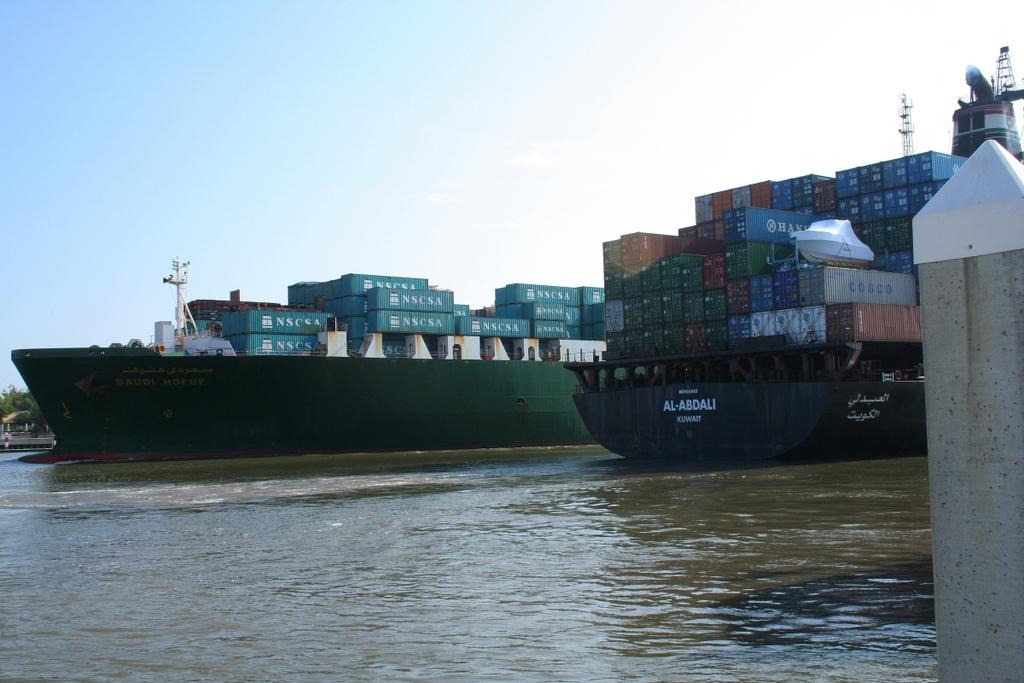<image>
Share a concise interpretation of the image provided. Two ships with tons of shipping containers are docked and one says Al-Abdali on the back. 